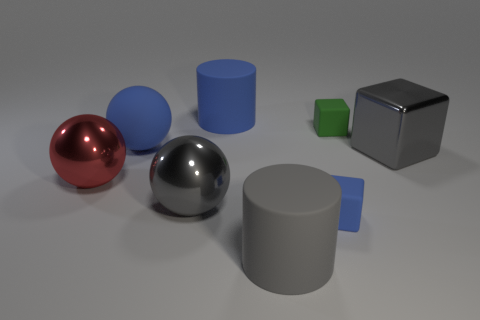Add 1 tiny red rubber cylinders. How many objects exist? 9 Subtract all cylinders. How many objects are left? 6 Add 5 big spheres. How many big spheres exist? 8 Subtract 1 gray cubes. How many objects are left? 7 Subtract all tiny blocks. Subtract all blue spheres. How many objects are left? 5 Add 2 gray rubber things. How many gray rubber things are left? 3 